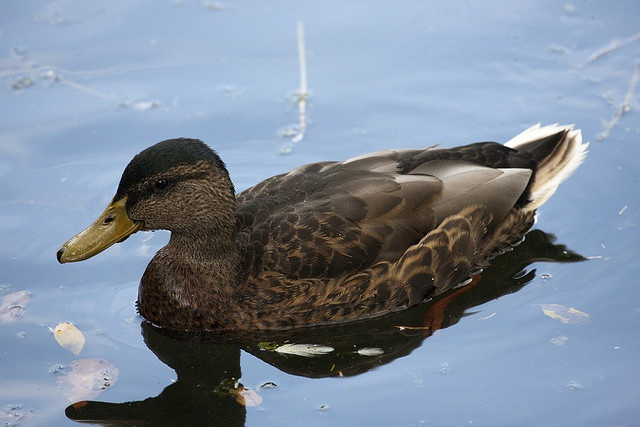Describe the objects in this image and their specific colors. I can see a bird in darkgray, black, gray, and maroon tones in this image. 